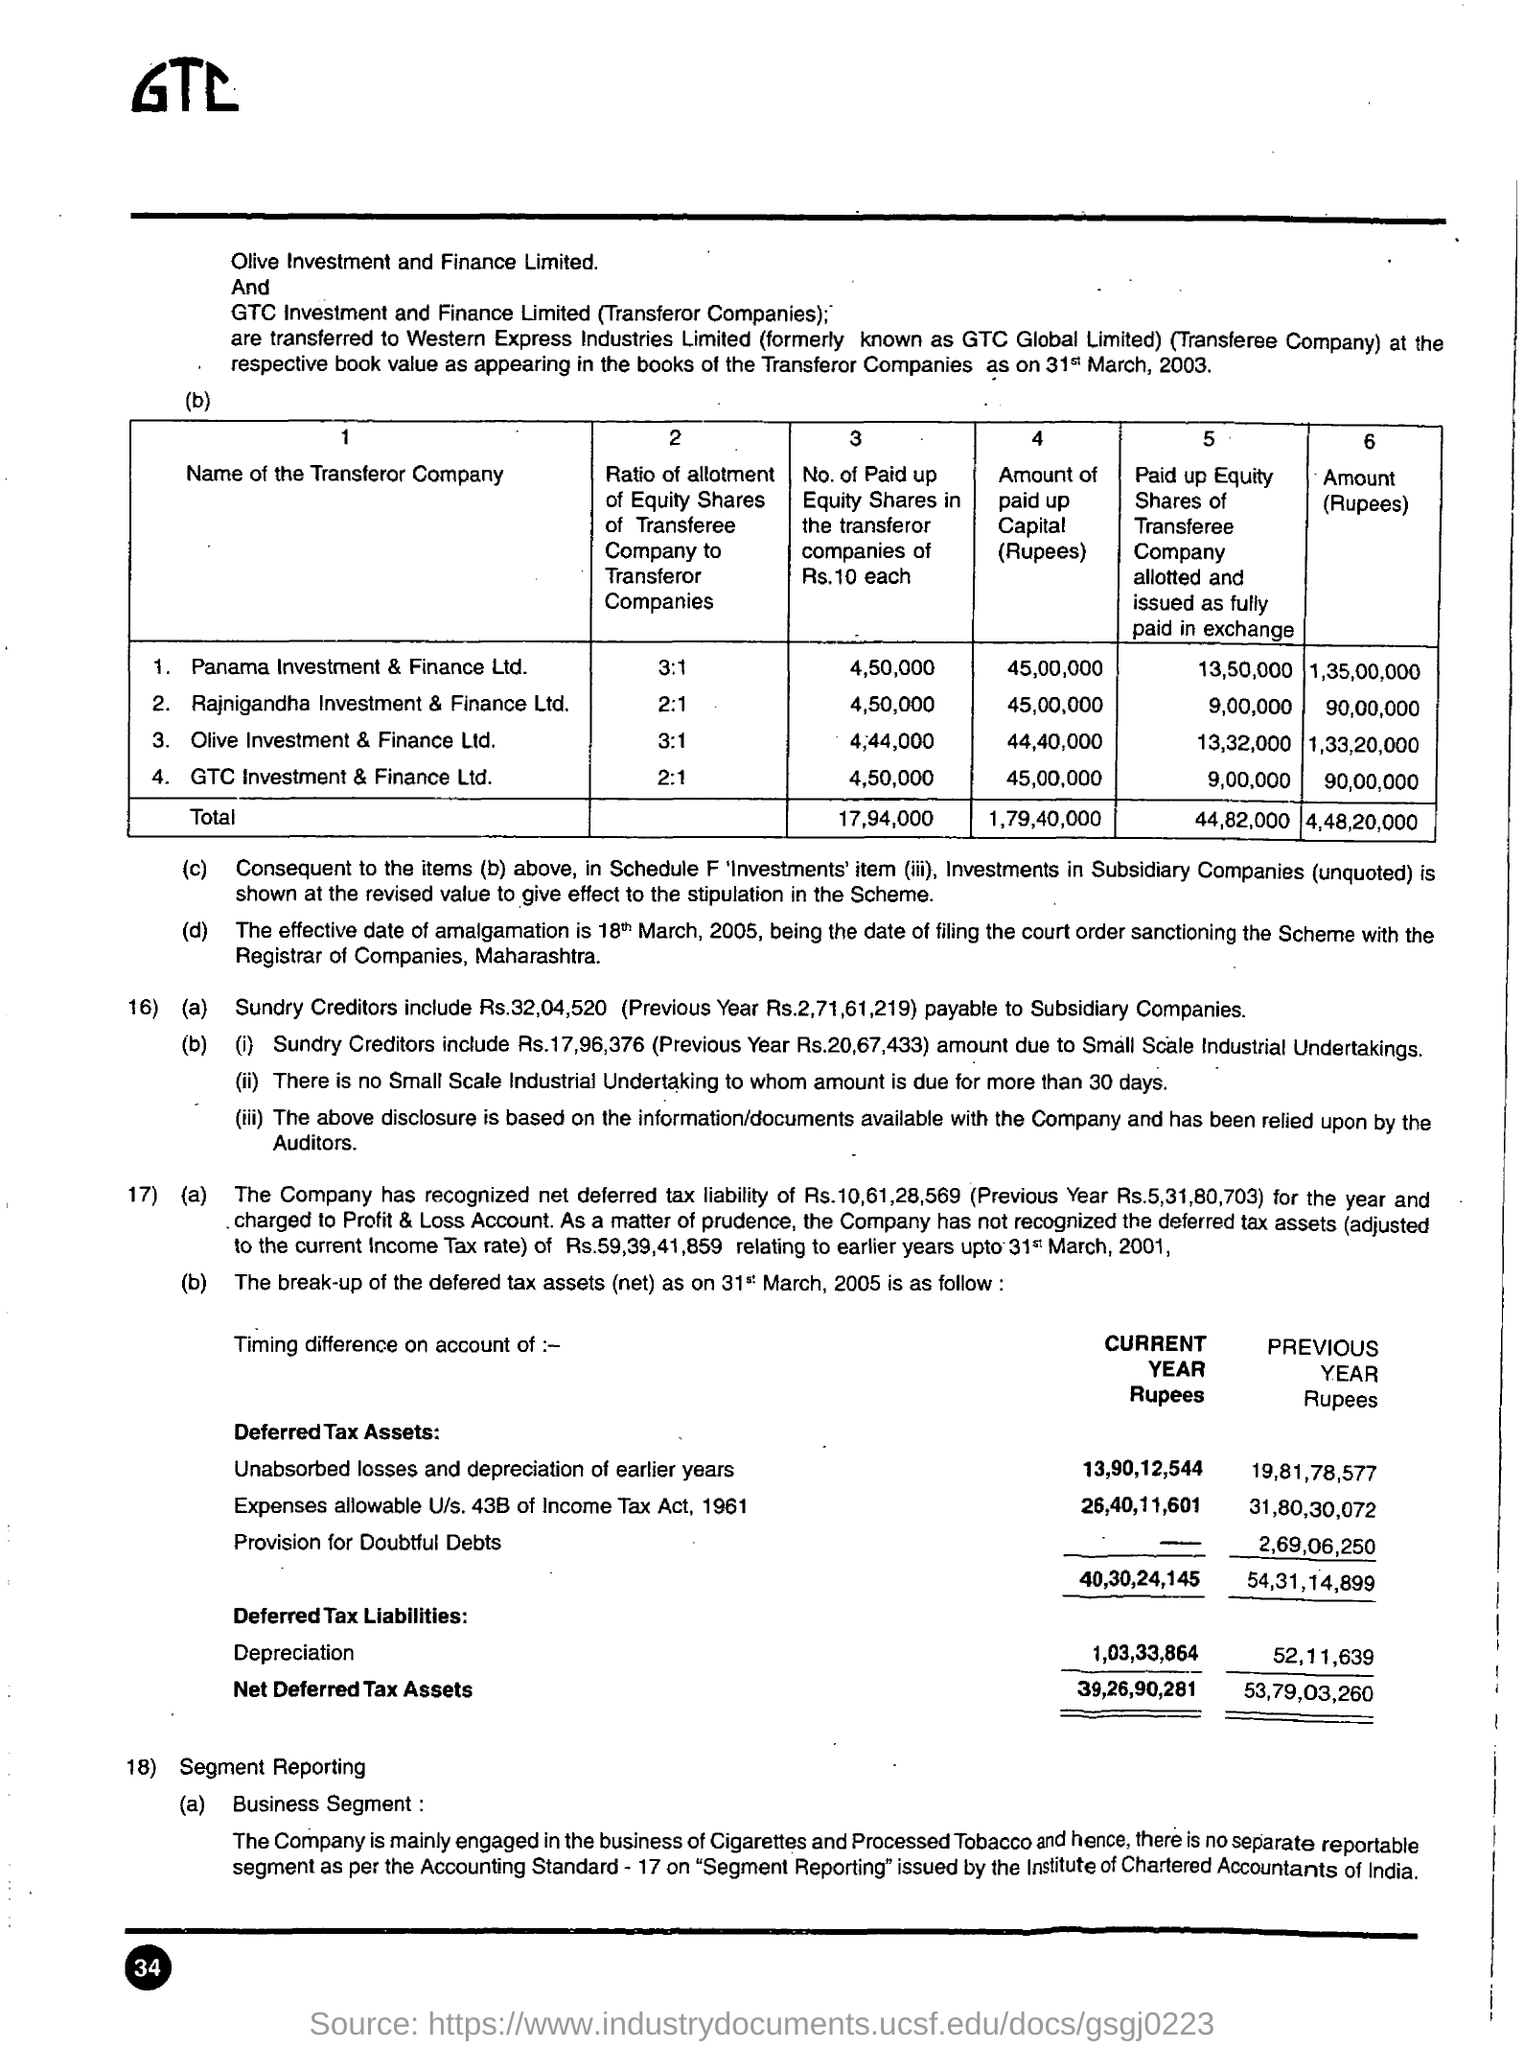What is the text written in the top left?
Ensure brevity in your answer.  GTC. 